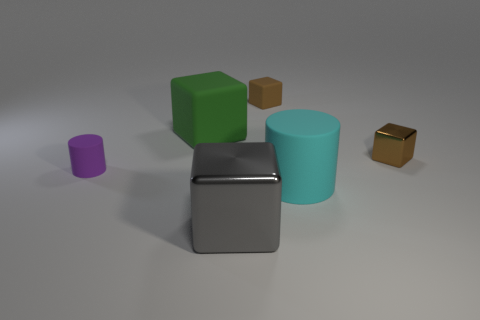There is a rubber block that is in front of the small brown block to the left of the big matte thing that is in front of the small brown metal block; what color is it?
Offer a very short reply. Green. Are there the same number of tiny brown matte things that are in front of the purple rubber cylinder and cyan objects to the left of the big cyan cylinder?
Offer a very short reply. Yes. The purple object that is the same size as the brown metallic block is what shape?
Your answer should be compact. Cylinder. Is there a tiny matte object that has the same color as the tiny rubber cylinder?
Give a very brief answer. No. The tiny object on the left side of the large green rubber object has what shape?
Provide a succinct answer. Cylinder. The big metal thing has what color?
Make the answer very short. Gray. There is another cylinder that is the same material as the tiny cylinder; what color is it?
Offer a very short reply. Cyan. How many large cyan things are the same material as the large gray block?
Make the answer very short. 0. There is a gray metal thing; how many rubber things are left of it?
Ensure brevity in your answer.  2. Are the small cube that is behind the tiny metal block and the big object that is behind the brown metal block made of the same material?
Provide a succinct answer. Yes. 